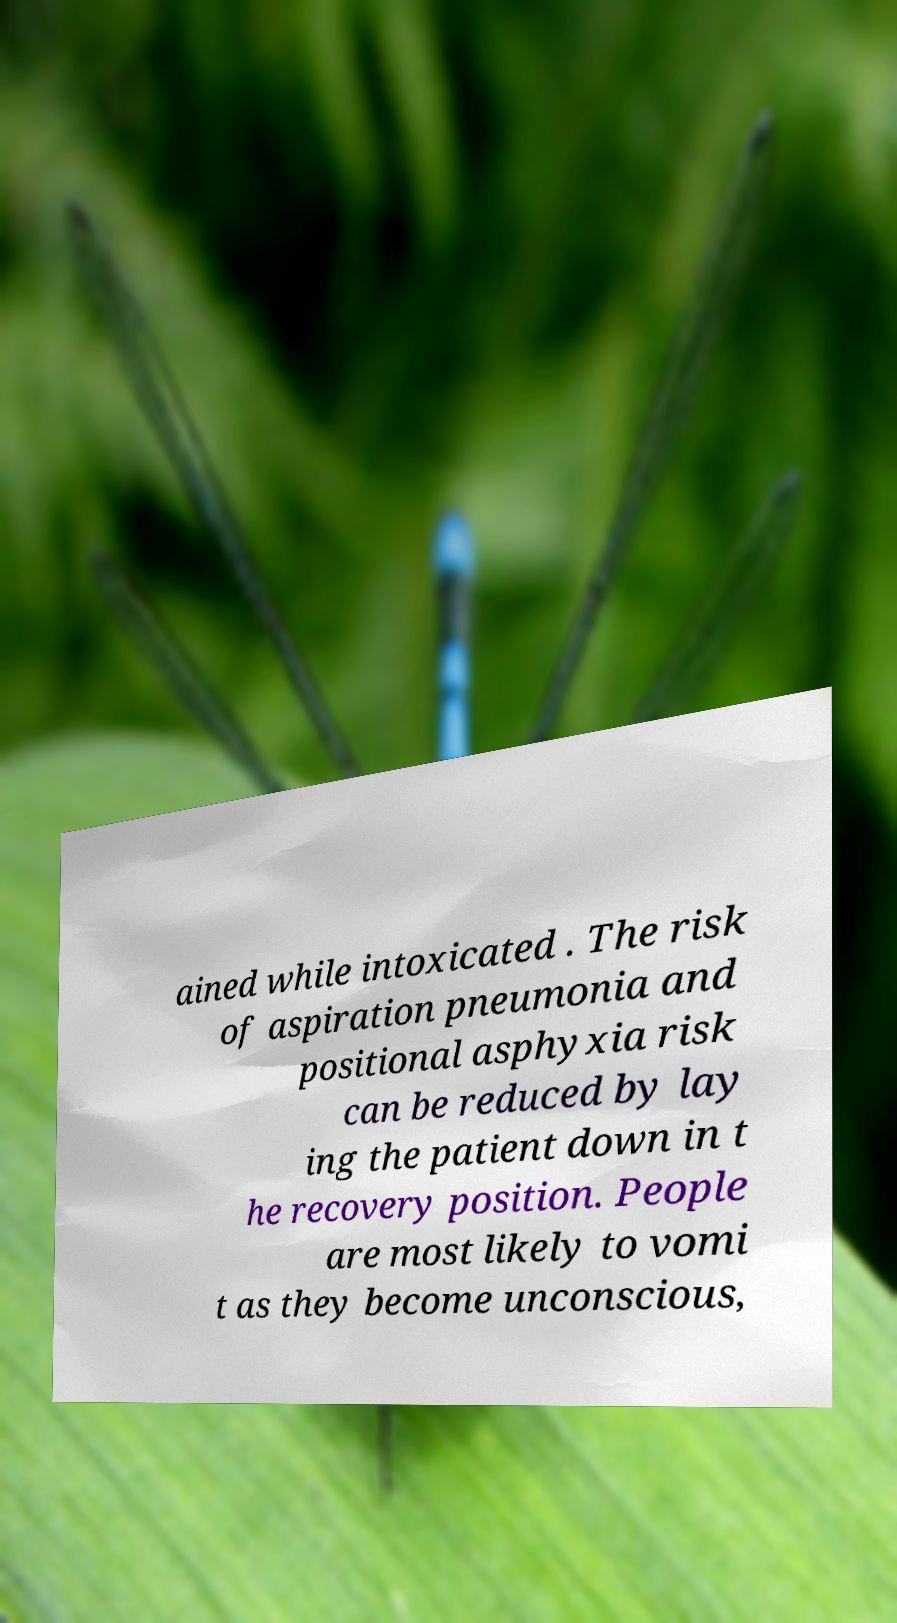Please read and relay the text visible in this image. What does it say? ained while intoxicated . The risk of aspiration pneumonia and positional asphyxia risk can be reduced by lay ing the patient down in t he recovery position. People are most likely to vomi t as they become unconscious, 